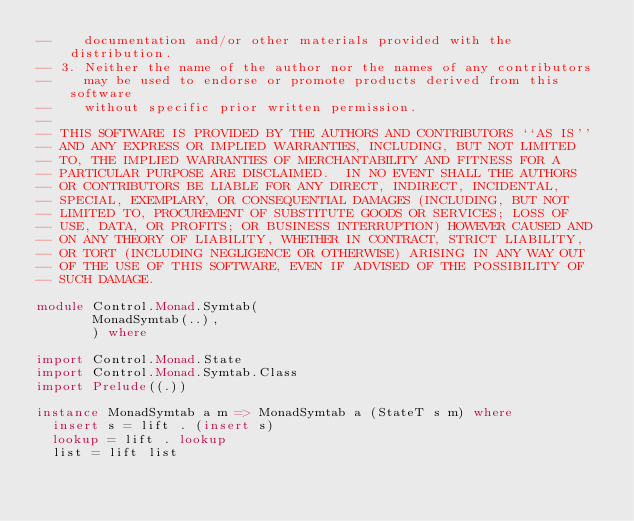<code> <loc_0><loc_0><loc_500><loc_500><_Haskell_>--    documentation and/or other materials provided with the distribution.
-- 3. Neither the name of the author nor the names of any contributors
--    may be used to endorse or promote products derived from this software
--    without specific prior written permission.
--
-- THIS SOFTWARE IS PROVIDED BY THE AUTHORS AND CONTRIBUTORS ``AS IS''
-- AND ANY EXPRESS OR IMPLIED WARRANTIES, INCLUDING, BUT NOT LIMITED
-- TO, THE IMPLIED WARRANTIES OF MERCHANTABILITY AND FITNESS FOR A
-- PARTICULAR PURPOSE ARE DISCLAIMED.  IN NO EVENT SHALL THE AUTHORS
-- OR CONTRIBUTORS BE LIABLE FOR ANY DIRECT, INDIRECT, INCIDENTAL,
-- SPECIAL, EXEMPLARY, OR CONSEQUENTIAL DAMAGES (INCLUDING, BUT NOT
-- LIMITED TO, PROCUREMENT OF SUBSTITUTE GOODS OR SERVICES; LOSS OF
-- USE, DATA, OR PROFITS; OR BUSINESS INTERRUPTION) HOWEVER CAUSED AND
-- ON ANY THEORY OF LIABILITY, WHETHER IN CONTRACT, STRICT LIABILITY,
-- OR TORT (INCLUDING NEGLIGENCE OR OTHERWISE) ARISING IN ANY WAY OUT
-- OF THE USE OF THIS SOFTWARE, EVEN IF ADVISED OF THE POSSIBILITY OF
-- SUCH DAMAGE.

module Control.Monad.Symtab(
       MonadSymtab(..),
       ) where

import Control.Monad.State
import Control.Monad.Symtab.Class
import Prelude((.))

instance MonadSymtab a m => MonadSymtab a (StateT s m) where
  insert s = lift . (insert s)
  lookup = lift . lookup
  list = lift list
</code> 